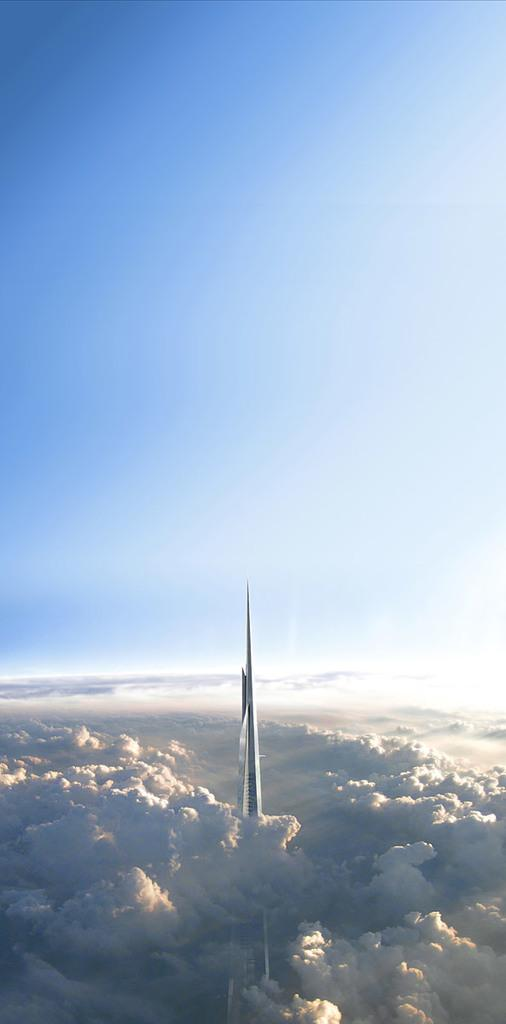What type of building is in the image? There is a skyscraper in the image. What can be seen around the skyscraper? Clouds are visible around the skyscraper. What is visible at the top of the image? The sky is visible at the top of the image. Are there any bears playing volleyball in the image? No, there are no bears or volleyball present in the image. 